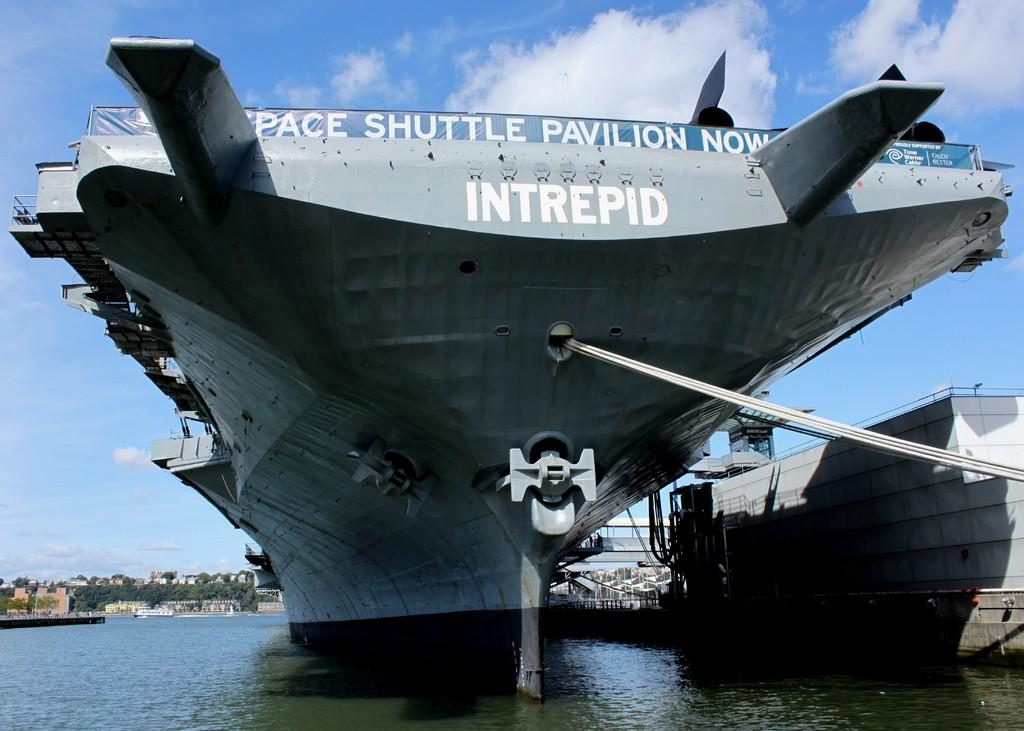Provide a one-sentence caption for the provided image. A picture of an aircraft carrier named the INTREPID with a banner saying the Space Shuttle Pavilion is now. 